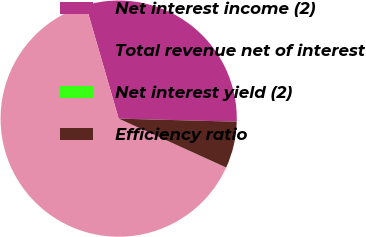Convert chart to OTSL. <chart><loc_0><loc_0><loc_500><loc_500><pie_chart><fcel>Net interest income (2)<fcel>Total revenue net of interest<fcel>Net interest yield (2)<fcel>Efficiency ratio<nl><fcel>29.9%<fcel>63.71%<fcel>0.01%<fcel>6.38%<nl></chart> 